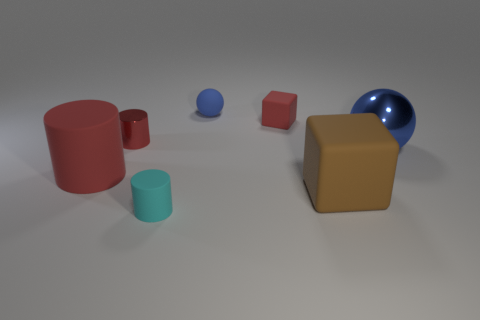There is a red object that is the same shape as the brown object; what is its material?
Provide a succinct answer. Rubber. Are there any other things that are the same size as the cyan cylinder?
Ensure brevity in your answer.  Yes. Are there any blue metallic things?
Your answer should be very brief. Yes. There is a tiny object in front of the blue thing in front of the red matte object behind the big cylinder; what is it made of?
Offer a very short reply. Rubber. There is a brown rubber object; is its shape the same as the blue thing that is in front of the metal cylinder?
Ensure brevity in your answer.  No. How many brown matte objects are the same shape as the tiny red matte thing?
Make the answer very short. 1. The blue metal thing has what shape?
Provide a short and direct response. Sphere. There is a red matte object that is behind the red cylinder that is in front of the blue metal object; what is its size?
Your response must be concise. Small. How many objects are either tiny red shiny objects or large yellow metallic blocks?
Offer a terse response. 1. Does the brown object have the same shape as the tiny metallic object?
Give a very brief answer. No. 